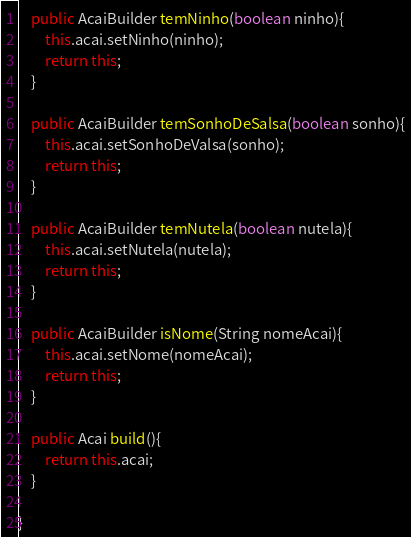Convert code to text. <code><loc_0><loc_0><loc_500><loc_500><_Java_>    public AcaiBuilder temNinho(boolean ninho){
        this.acai.setNinho(ninho);
        return this;
    }
    
    public AcaiBuilder temSonhoDeSalsa(boolean sonho){
        this.acai.setSonhoDeValsa(sonho);
        return this;
    }
    
    public AcaiBuilder temNutela(boolean nutela){
        this.acai.setNutela(nutela);
        return this;
    }
    
    public AcaiBuilder isNome(String nomeAcai){
        this.acai.setNome(nomeAcai);
        return this;
    }
    
    public Acai build(){
        return this.acai;
    }
    
}
</code> 